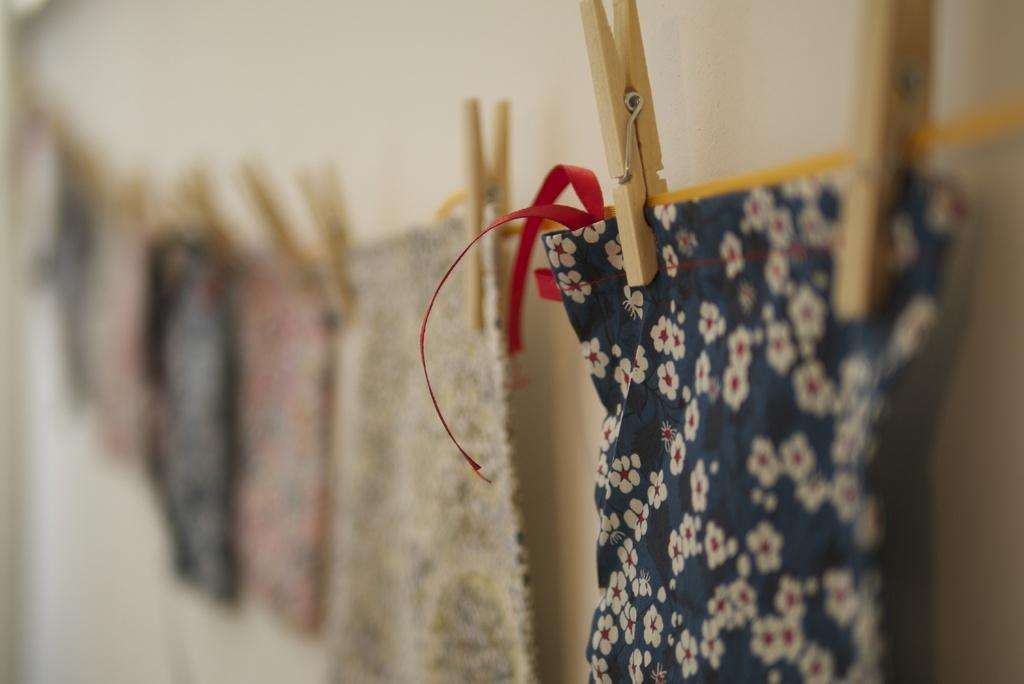What is being hung in the image? There are clothes hanged on a rope in the image. What are the wooden objects used for in the image? There are wooden clips in the image, which are likely used to hold the clothes on the rope. What type of heart-shaped object can be seen in the image? There is no heart-shaped object present in the image. What is the cow doing in the image? There is no cow present in the image. 